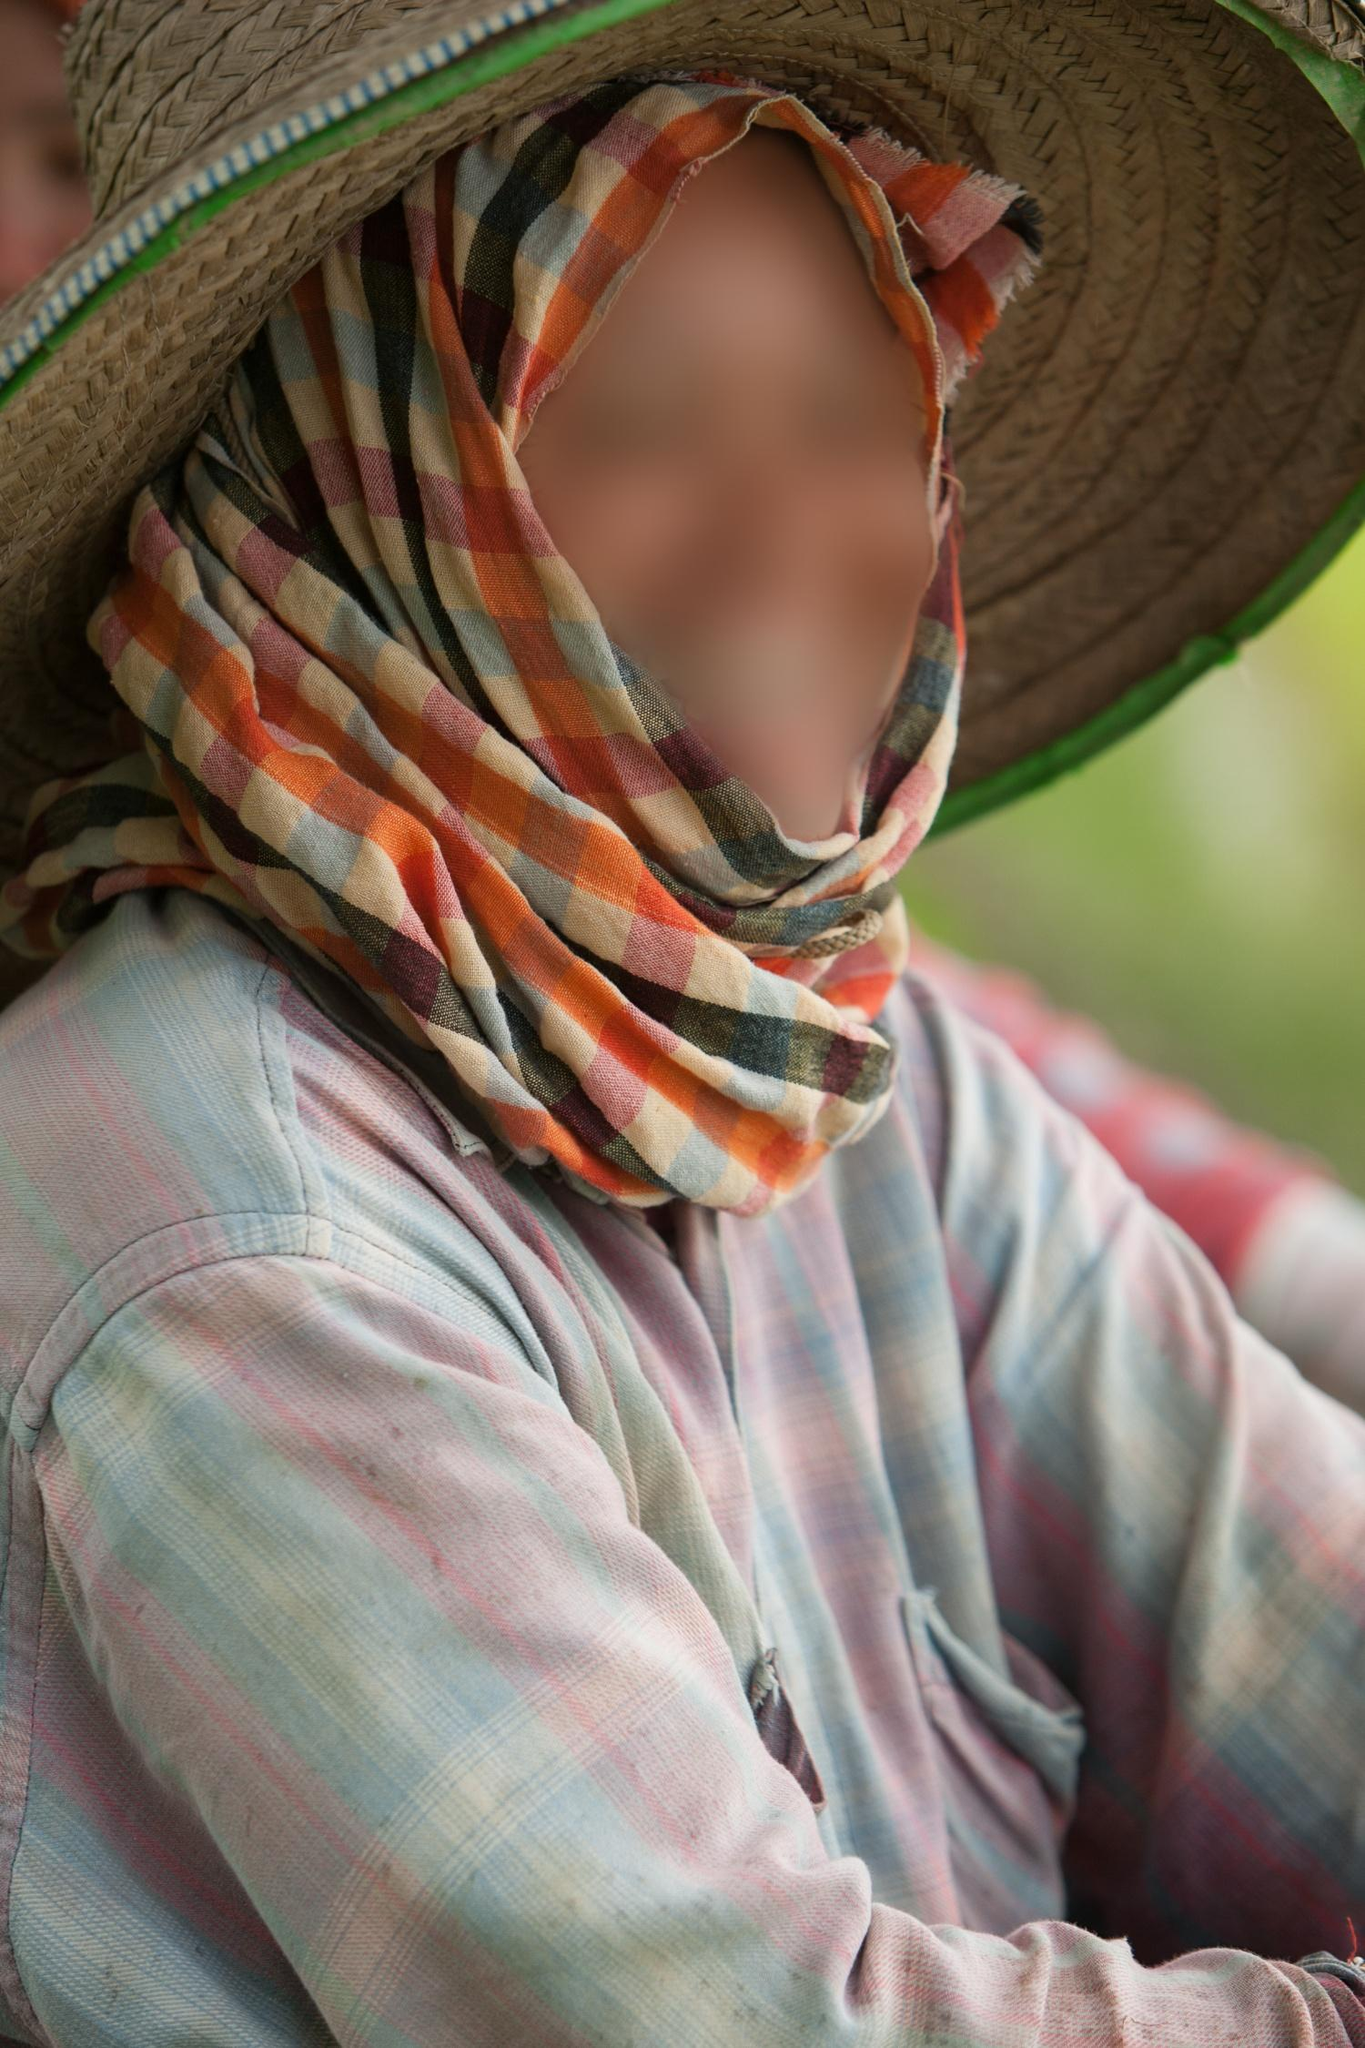What might the person be thinking or feeling in this setting? The person's eyes, visible through the layers of the colorful scarf, carry an expression that could suggest introspection or a peaceful contemplation of their surroundings. The soft array of greens in the blurry background and the casual, comfortable attire might indicate they are in a serene, possibly secluded location, enjoying a moment of solitude. Such settings often invite moments of reflection, perhaps about one's life, nature’s beauty, or a brief escape from everyday stresses. 